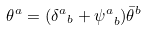Convert formula to latex. <formula><loc_0><loc_0><loc_500><loc_500>\theta ^ { a } = ( { \delta ^ { a } } _ { b } + { \psi ^ { a } } _ { b } ) \bar { \theta } ^ { b }</formula> 